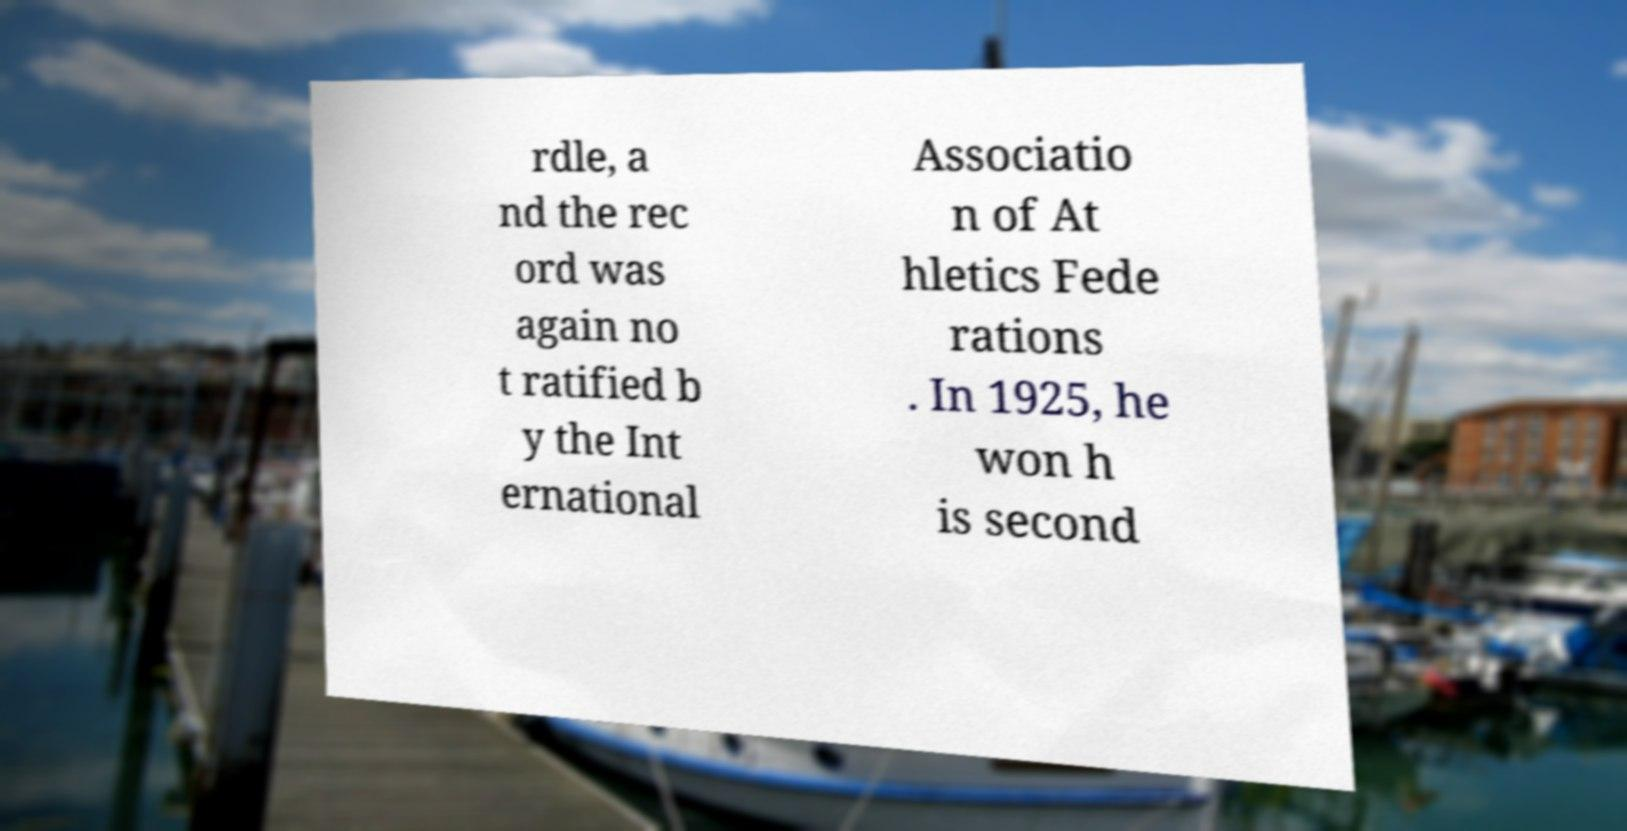Could you extract and type out the text from this image? rdle, a nd the rec ord was again no t ratified b y the Int ernational Associatio n of At hletics Fede rations . In 1925, he won h is second 